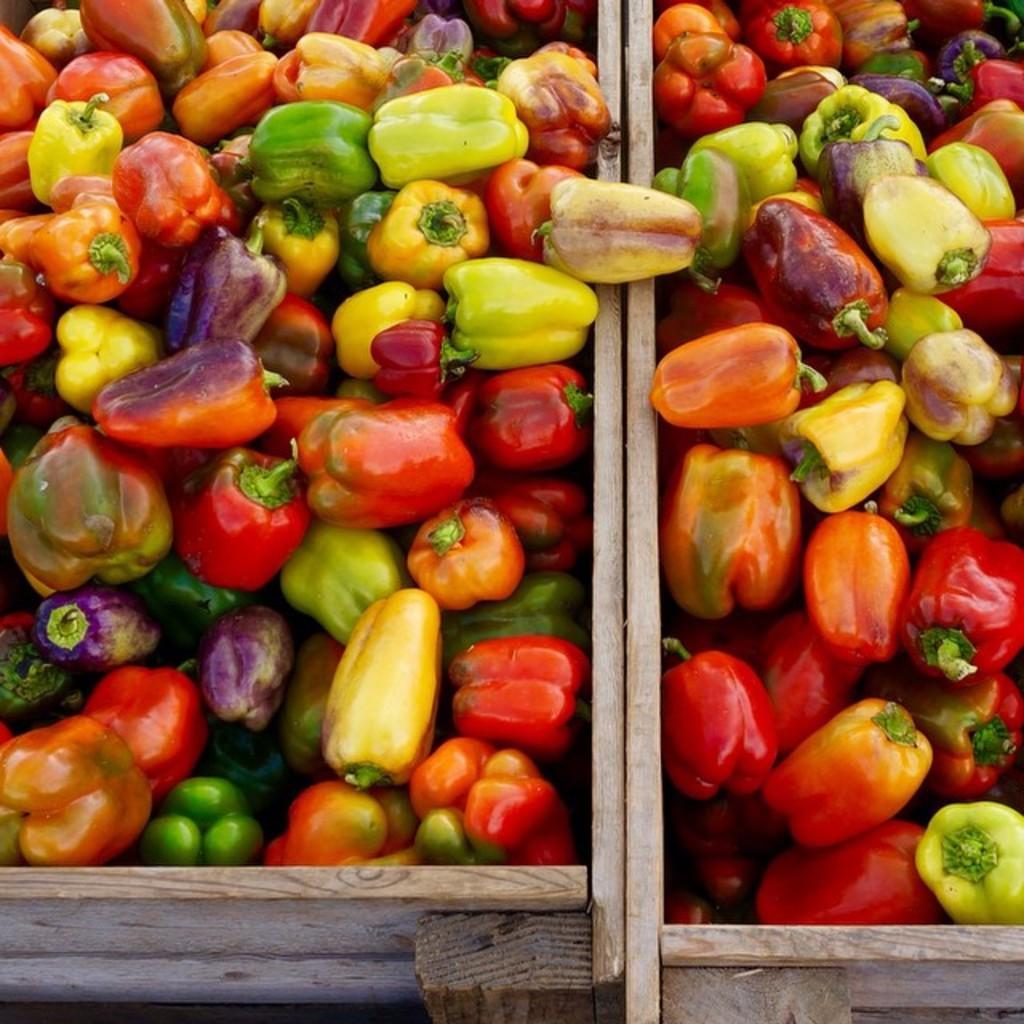In one or two sentences, can you explain what this image depicts? This image consists of capsicum which are in green and color are kept in the wooden boxes. 